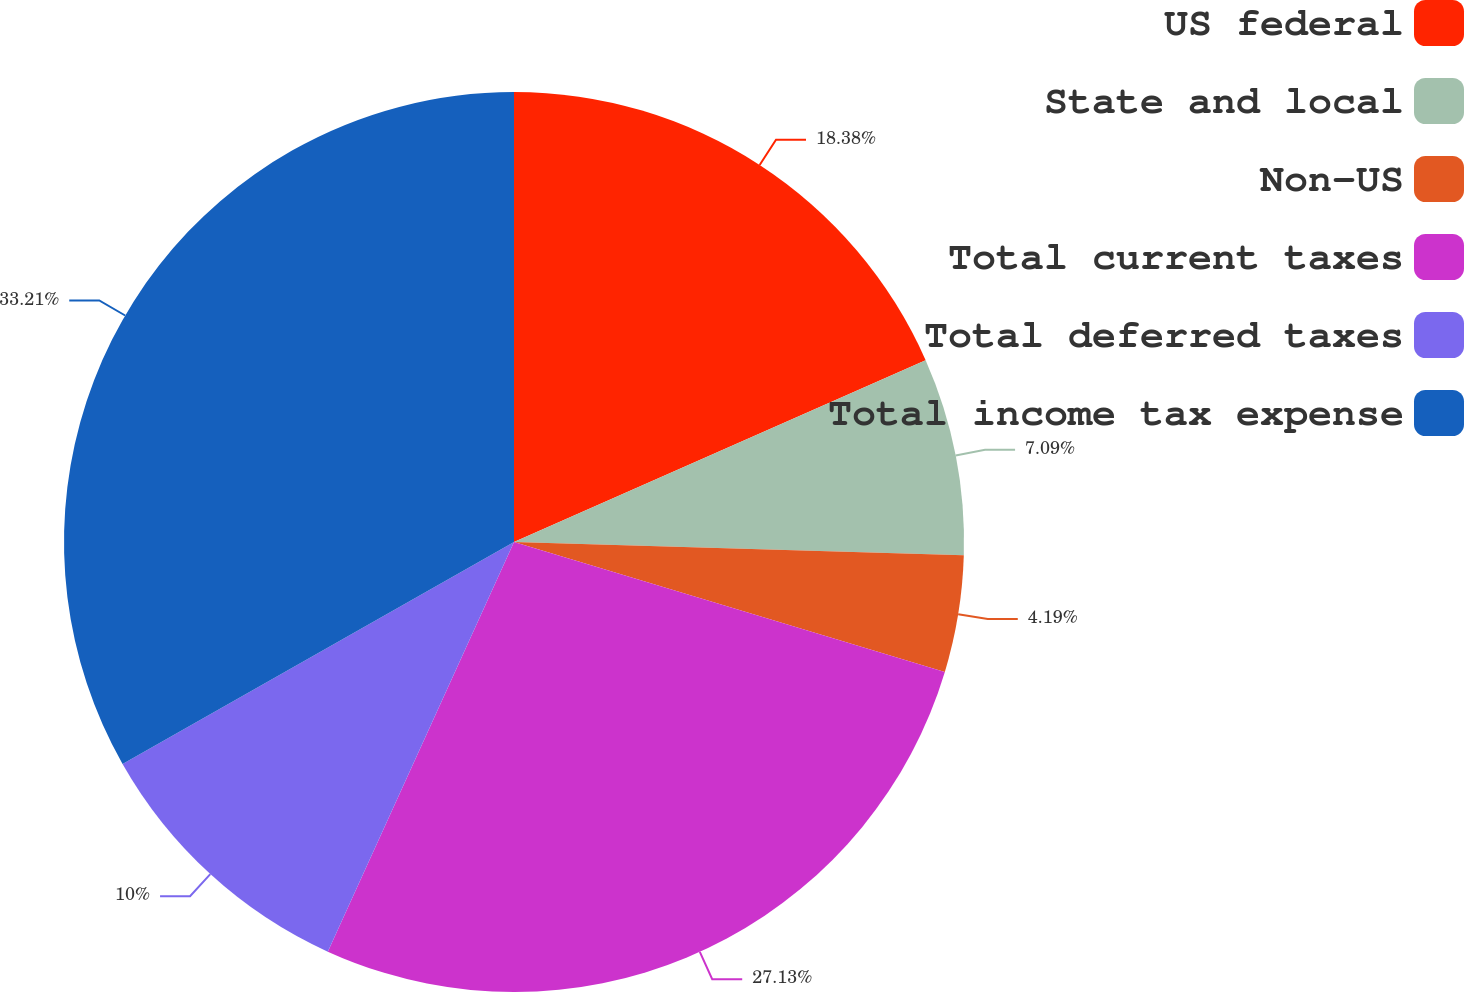Convert chart. <chart><loc_0><loc_0><loc_500><loc_500><pie_chart><fcel>US federal<fcel>State and local<fcel>Non-US<fcel>Total current taxes<fcel>Total deferred taxes<fcel>Total income tax expense<nl><fcel>18.38%<fcel>7.09%<fcel>4.19%<fcel>27.13%<fcel>10.0%<fcel>33.21%<nl></chart> 